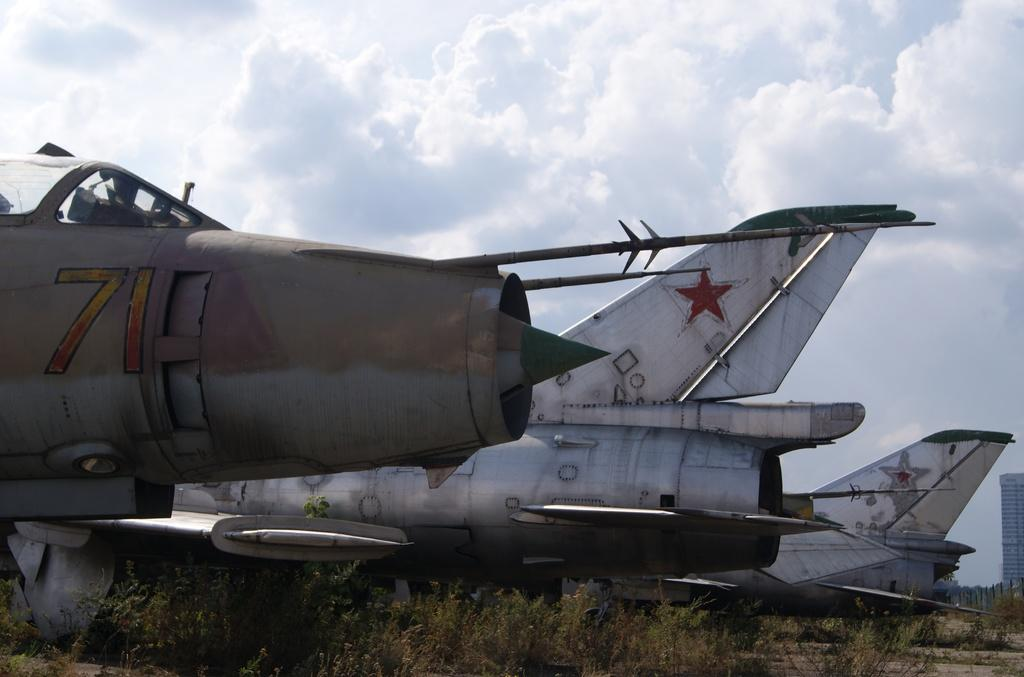<image>
Share a concise interpretation of the image provided. Some old military planes sit in a field, one numbered 71. 